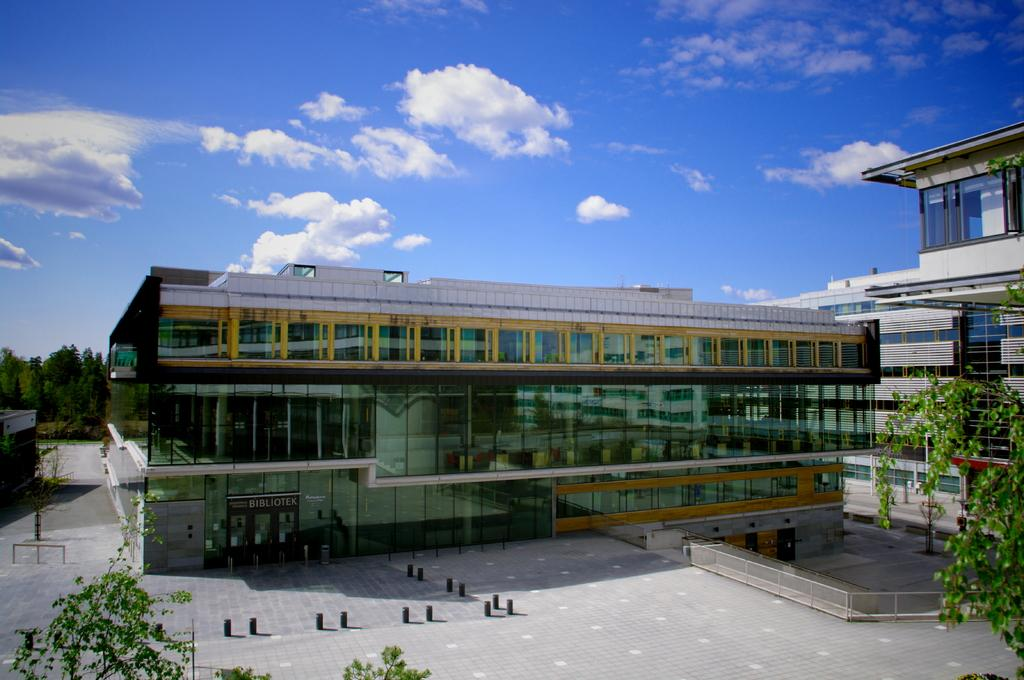What type of structures are visible in the image? There are buildings in the image. Where can trees be seen in the image? Trees can be seen on both the right and left sides of the image. What is on top of the buildings? There are glasses on the buildings. What is visible at the top of the image? The sky is visible at the top of the image. What can be seen in the sky? Clouds are present in the sky. How many bubbles are floating above the trees on the right side of the image? There are no bubbles present in the image; it only features buildings, trees, glasses, and clouds in the sky. 